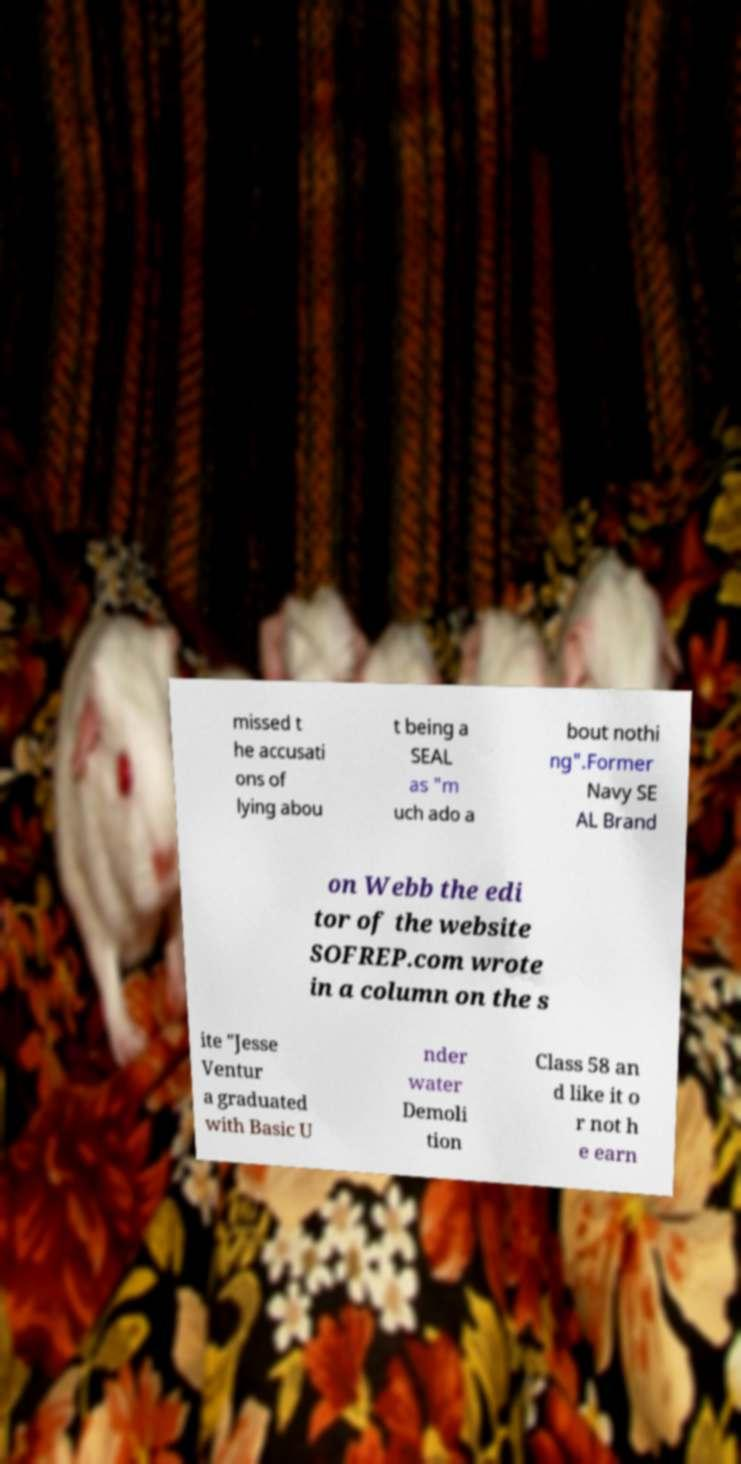I need the written content from this picture converted into text. Can you do that? missed t he accusati ons of lying abou t being a SEAL as "m uch ado a bout nothi ng".Former Navy SE AL Brand on Webb the edi tor of the website SOFREP.com wrote in a column on the s ite "Jesse Ventur a graduated with Basic U nder water Demoli tion Class 58 an d like it o r not h e earn 